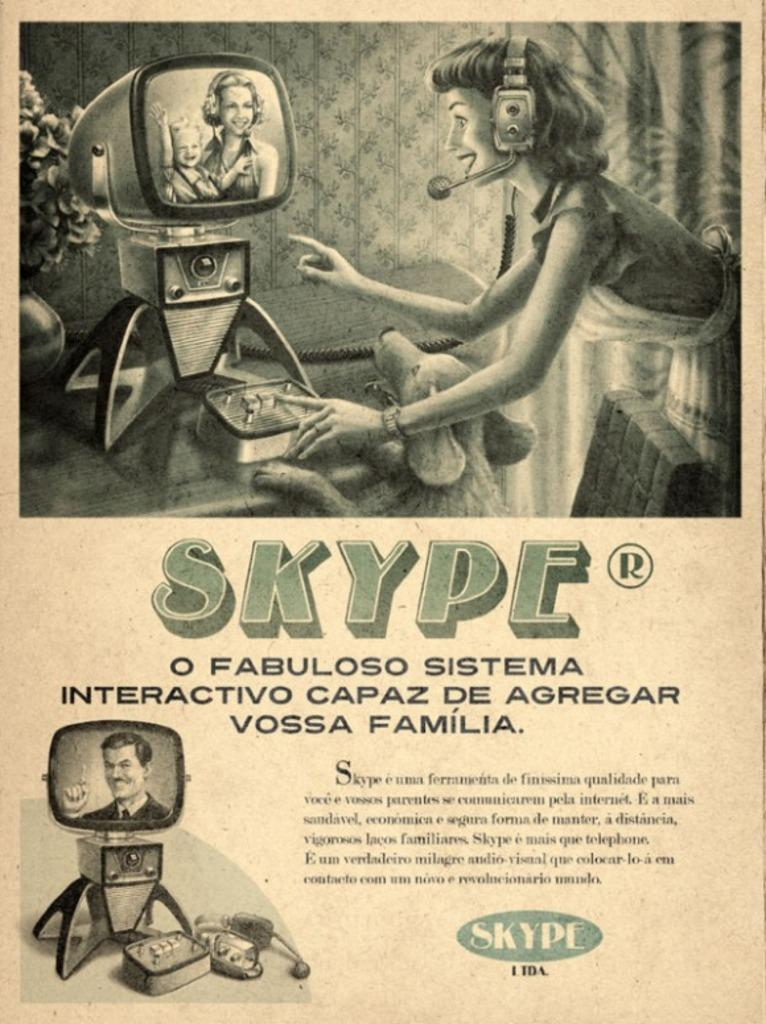What type of printed material is shown in the image? The image is a pamphlet. What types of images can be seen on the pamphlet? There are images of televisions, people, a dog, and a houseplant on the pamphlet. Are there any words on the pamphlet? Yes, there are words on the pamphlet. What type of fear does the dog have in the image? There is no indication of fear in the image; the dog is simply depicted as an image on the pamphlet. Can you tell me how many kittens are present in the image? There are no kittens present in the image; only a dog, people, televisions, and a houseplant are depicted. 